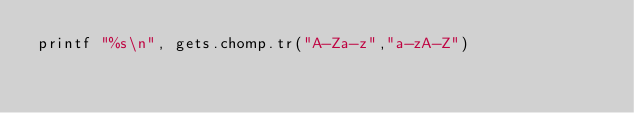<code> <loc_0><loc_0><loc_500><loc_500><_Ruby_>printf "%s\n", gets.chomp.tr("A-Za-z","a-zA-Z")</code> 